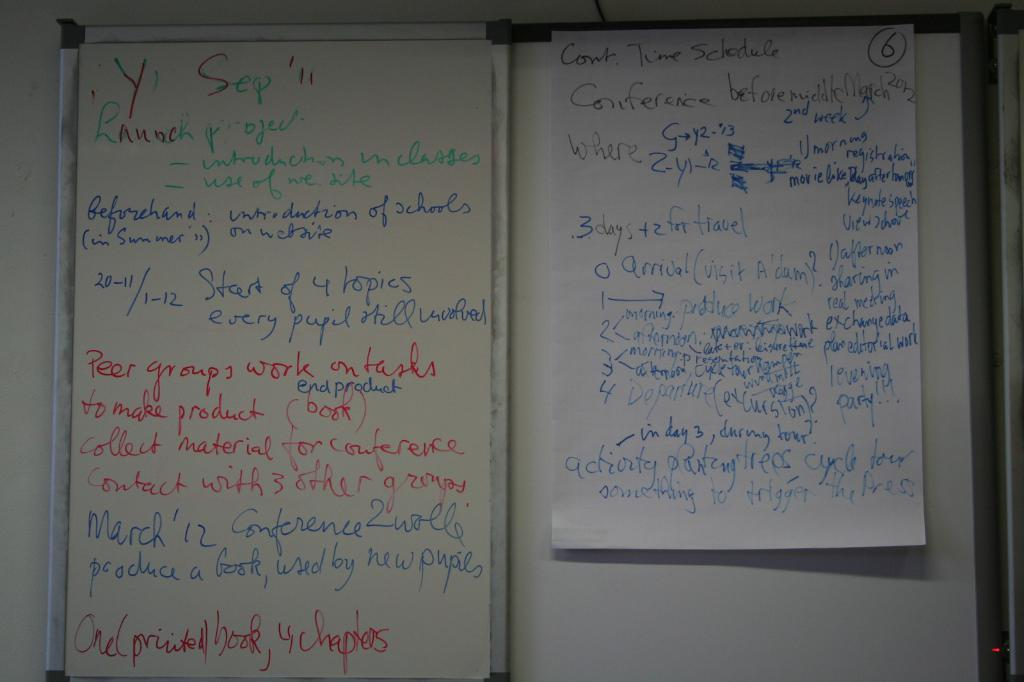<image>
Provide a brief description of the given image. The writing on the white board talks about a March 12th conference. 